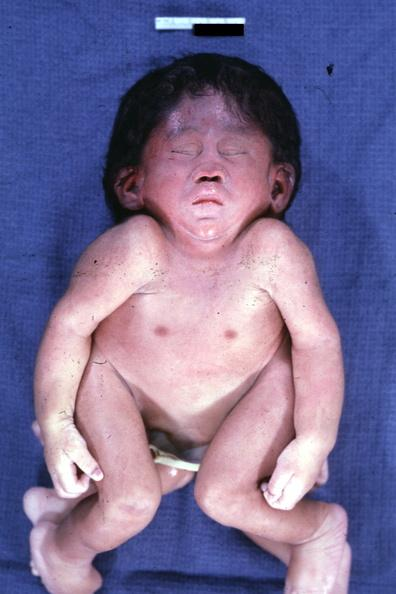what is present?
Answer the question using a single word or phrase. Cephalothoracopagus janiceps 